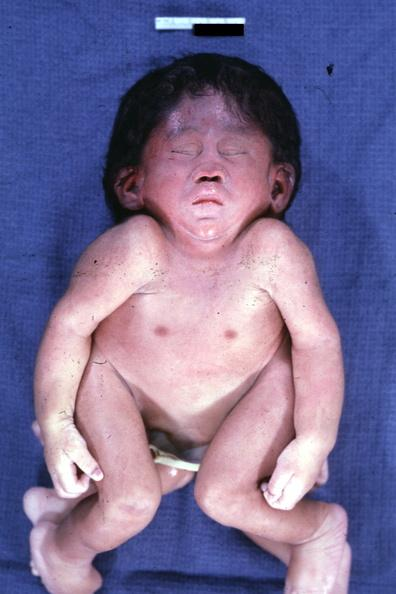what is present?
Answer the question using a single word or phrase. Cephalothoracopagus janiceps 